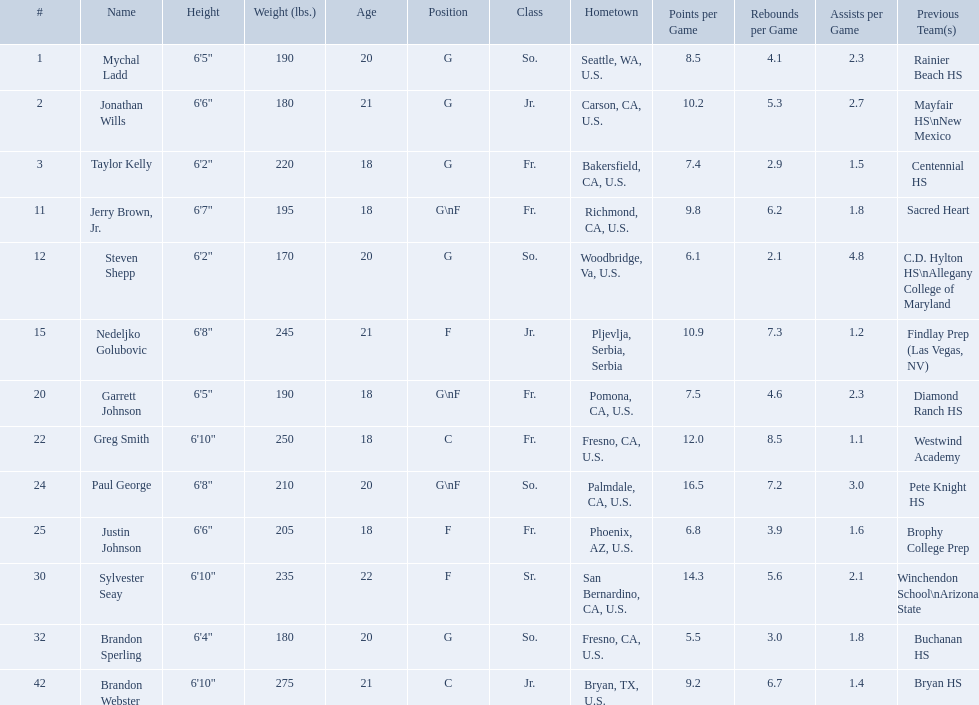What are the listed classes of the players? So., Jr., Fr., Fr., So., Jr., Fr., Fr., So., Fr., Sr., So., Jr. Which of these is not from the us? Jr. To which name does that entry correspond to? Nedeljko Golubovic. Where were all of the players born? So., Jr., Fr., Fr., So., Jr., Fr., Fr., So., Fr., Sr., So., Jr. Who is the one from serbia? Nedeljko Golubovic. Which players are forwards? Nedeljko Golubovic, Paul George, Justin Johnson, Sylvester Seay. What are the heights of these players? Nedeljko Golubovic, 6'8", Paul George, 6'8", Justin Johnson, 6'6", Sylvester Seay, 6'10". Of these players, who is the shortest? Justin Johnson. Who are all the players in the 2009-10 fresno state bulldogs men's basketball team? Mychal Ladd, Jonathan Wills, Taylor Kelly, Jerry Brown, Jr., Steven Shepp, Nedeljko Golubovic, Garrett Johnson, Greg Smith, Paul George, Justin Johnson, Sylvester Seay, Brandon Sperling, Brandon Webster. Of these players, who are the ones who play forward? Jerry Brown, Jr., Nedeljko Golubovic, Garrett Johnson, Paul George, Justin Johnson, Sylvester Seay. Of these players, which ones only play forward and no other position? Nedeljko Golubovic, Justin Johnson, Sylvester Seay. Of these players, who is the shortest? Justin Johnson. Who are all of the players? Mychal Ladd, Jonathan Wills, Taylor Kelly, Jerry Brown, Jr., Steven Shepp, Nedeljko Golubovic, Garrett Johnson, Greg Smith, Paul George, Justin Johnson, Sylvester Seay, Brandon Sperling, Brandon Webster. What are their heights? 6'5", 6'6", 6'2", 6'7", 6'2", 6'8", 6'5", 6'10", 6'8", 6'6", 6'10", 6'4", 6'10". Along with taylor kelly, which other player is shorter than 6'3? Steven Shepp. Who are the players for the 2009-10 fresno state bulldogs men's basketball team? Mychal Ladd, Jonathan Wills, Taylor Kelly, Jerry Brown, Jr., Steven Shepp, Nedeljko Golubovic, Garrett Johnson, Greg Smith, Paul George, Justin Johnson, Sylvester Seay, Brandon Sperling, Brandon Webster. What are their heights? 6'5", 6'6", 6'2", 6'7", 6'2", 6'8", 6'5", 6'10", 6'8", 6'6", 6'10", 6'4", 6'10". What is the shortest height? 6'2", 6'2". What is the lowest weight? 6'2". Which player is it? Steven Shepp. 